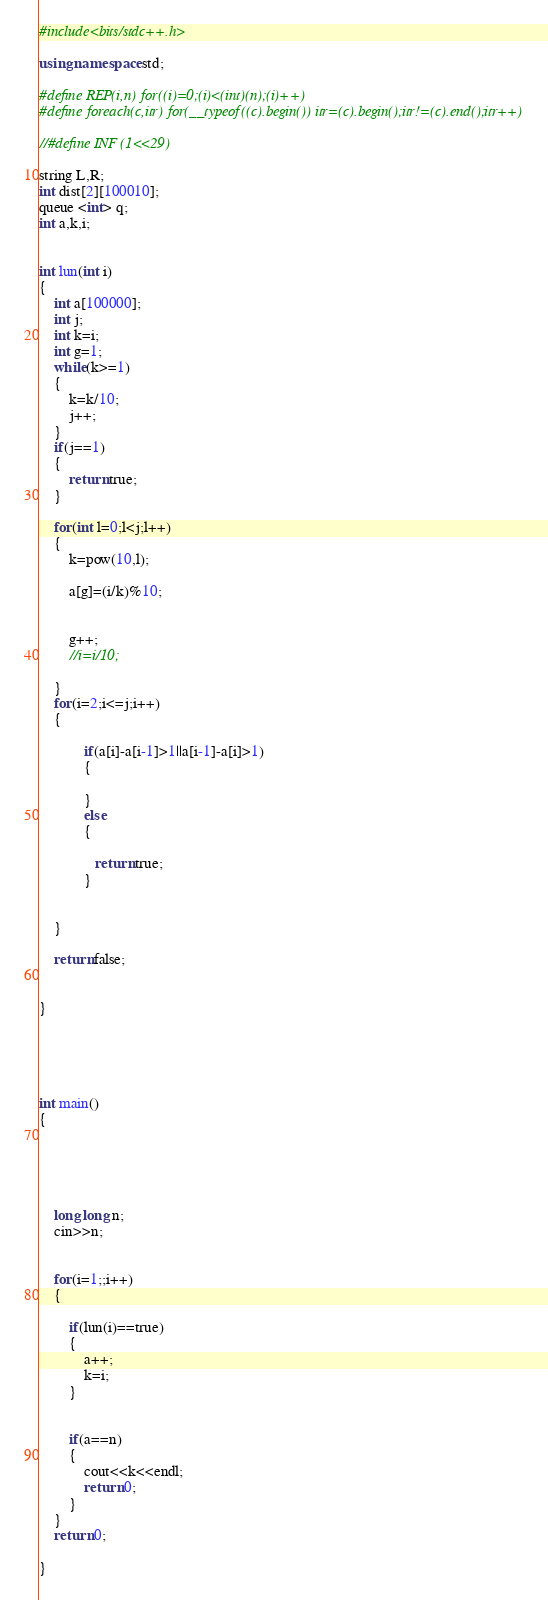<code> <loc_0><loc_0><loc_500><loc_500><_C++_>#include<bits/stdc++.h>

using namespace std;

#define REP(i,n) for((i)=0;(i)<(int)(n);(i)++)
#define foreach(c,itr) for(__typeof((c).begin()) itr=(c).begin();itr!=(c).end();itr++)

//#define INF (1<<29)

string L,R;
int dist[2][100010];
queue <int> q;
int a,k,i;


int lun(int i)
{
	int a[100000];
	int j;
	int k=i;
	int g=1;
	while(k>=1)
	{
		k=k/10;
		j++;
	}
	if(j==1)
    {
		return true;
	}
	
	for(int l=0;l<j;l++)
	{
		k=pow(10,l);

		a[g]=(i/k)%10;


		g++;
		//i=i/10;

	}
	for(i=2;i<=j;i++)
	{

			if(a[i]-a[i-1]>1||a[i-1]-a[i]>1)
		   	{

		   	}
		   	else
		   	{

			   return true;
		    }


	}

	return false;

	
}





int main()
{





	long long n;
	cin>>n;


	for(i=1;;i++)
	{
		
		if(lun(i)==true)
		{
			a++;
			k=i;
		}

		
		if(a==n)
		{
			cout<<k<<endl;
			return 0;
		}
	}
	return 0;

}

</code> 